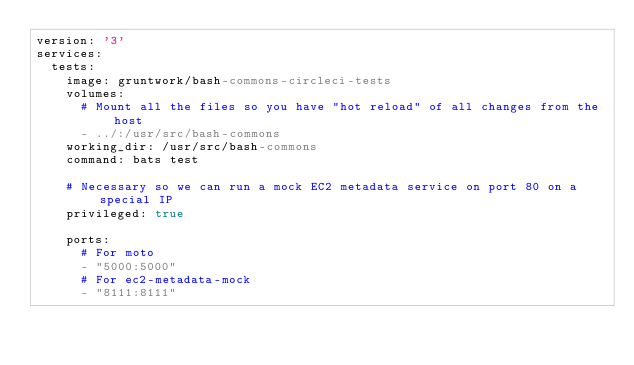<code> <loc_0><loc_0><loc_500><loc_500><_YAML_>version: '3'
services:
  tests:
    image: gruntwork/bash-commons-circleci-tests
    volumes:
      # Mount all the files so you have "hot reload" of all changes from the host
      - ../:/usr/src/bash-commons
    working_dir: /usr/src/bash-commons
    command: bats test

    # Necessary so we can run a mock EC2 metadata service on port 80 on a special IP
    privileged: true

    ports:
      # For moto
      - "5000:5000"
      # For ec2-metadata-mock
      - "8111:8111"
</code> 